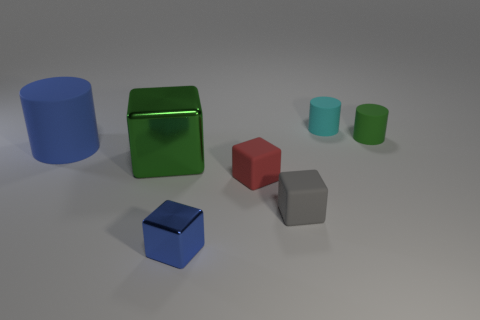Subtract 1 blocks. How many blocks are left? 3 Add 1 tiny gray blocks. How many objects exist? 8 Subtract all cylinders. How many objects are left? 4 Subtract all tiny cyan objects. Subtract all cylinders. How many objects are left? 3 Add 1 small cyan things. How many small cyan things are left? 2 Add 1 gray shiny spheres. How many gray shiny spheres exist? 1 Subtract 0 red balls. How many objects are left? 7 